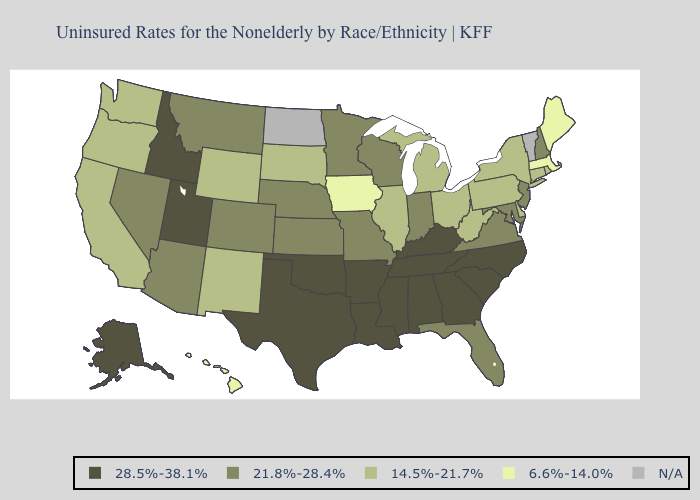Does Montana have the highest value in the USA?
Write a very short answer. No. What is the lowest value in the USA?
Short answer required. 6.6%-14.0%. Does Florida have the highest value in the USA?
Quick response, please. No. What is the value of Vermont?
Give a very brief answer. N/A. What is the value of Idaho?
Be succinct. 28.5%-38.1%. What is the highest value in the USA?
Be succinct. 28.5%-38.1%. Among the states that border North Dakota , does Montana have the lowest value?
Concise answer only. No. What is the value of Delaware?
Keep it brief. 14.5%-21.7%. What is the value of Ohio?
Give a very brief answer. 14.5%-21.7%. What is the value of Maine?
Be succinct. 6.6%-14.0%. Name the states that have a value in the range 21.8%-28.4%?
Keep it brief. Arizona, Colorado, Florida, Indiana, Kansas, Maryland, Minnesota, Missouri, Montana, Nebraska, Nevada, New Hampshire, New Jersey, Virginia, Wisconsin. Name the states that have a value in the range 21.8%-28.4%?
Short answer required. Arizona, Colorado, Florida, Indiana, Kansas, Maryland, Minnesota, Missouri, Montana, Nebraska, Nevada, New Hampshire, New Jersey, Virginia, Wisconsin. What is the lowest value in states that border Mississippi?
Quick response, please. 28.5%-38.1%. 